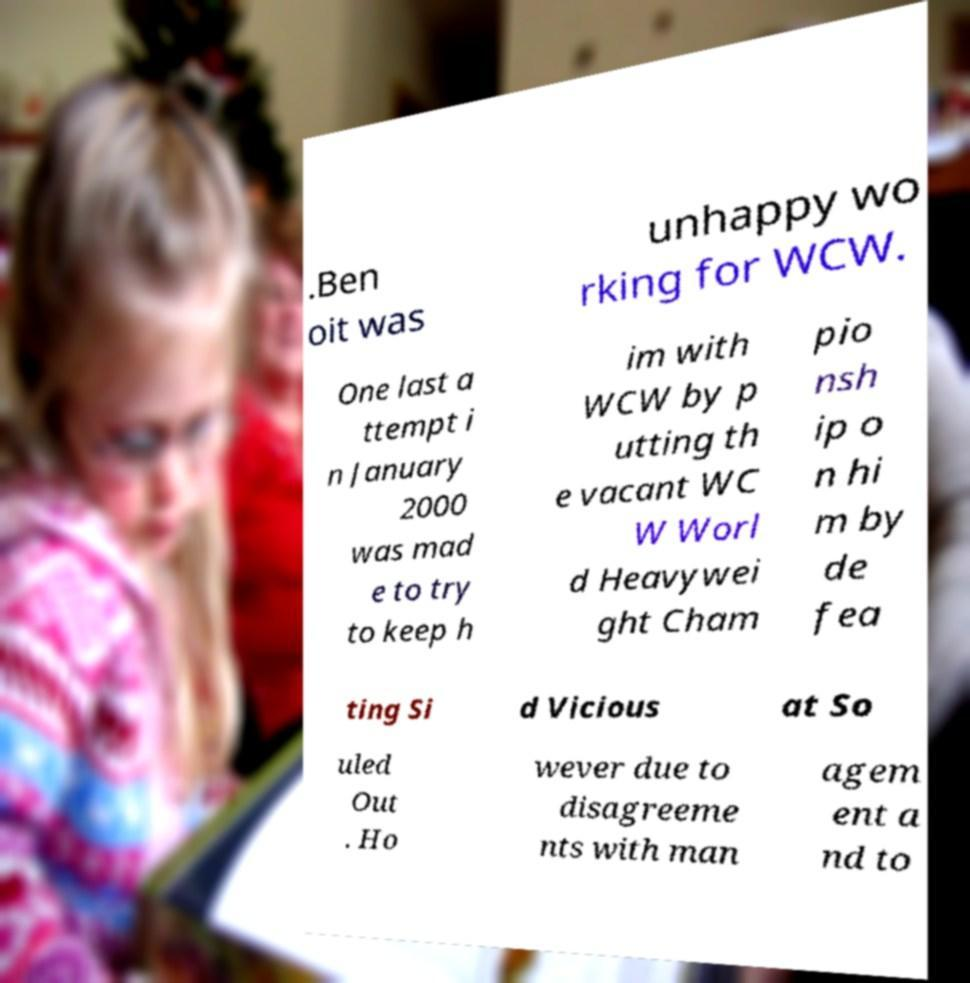Please identify and transcribe the text found in this image. .Ben oit was unhappy wo rking for WCW. One last a ttempt i n January 2000 was mad e to try to keep h im with WCW by p utting th e vacant WC W Worl d Heavywei ght Cham pio nsh ip o n hi m by de fea ting Si d Vicious at So uled Out . Ho wever due to disagreeme nts with man agem ent a nd to 